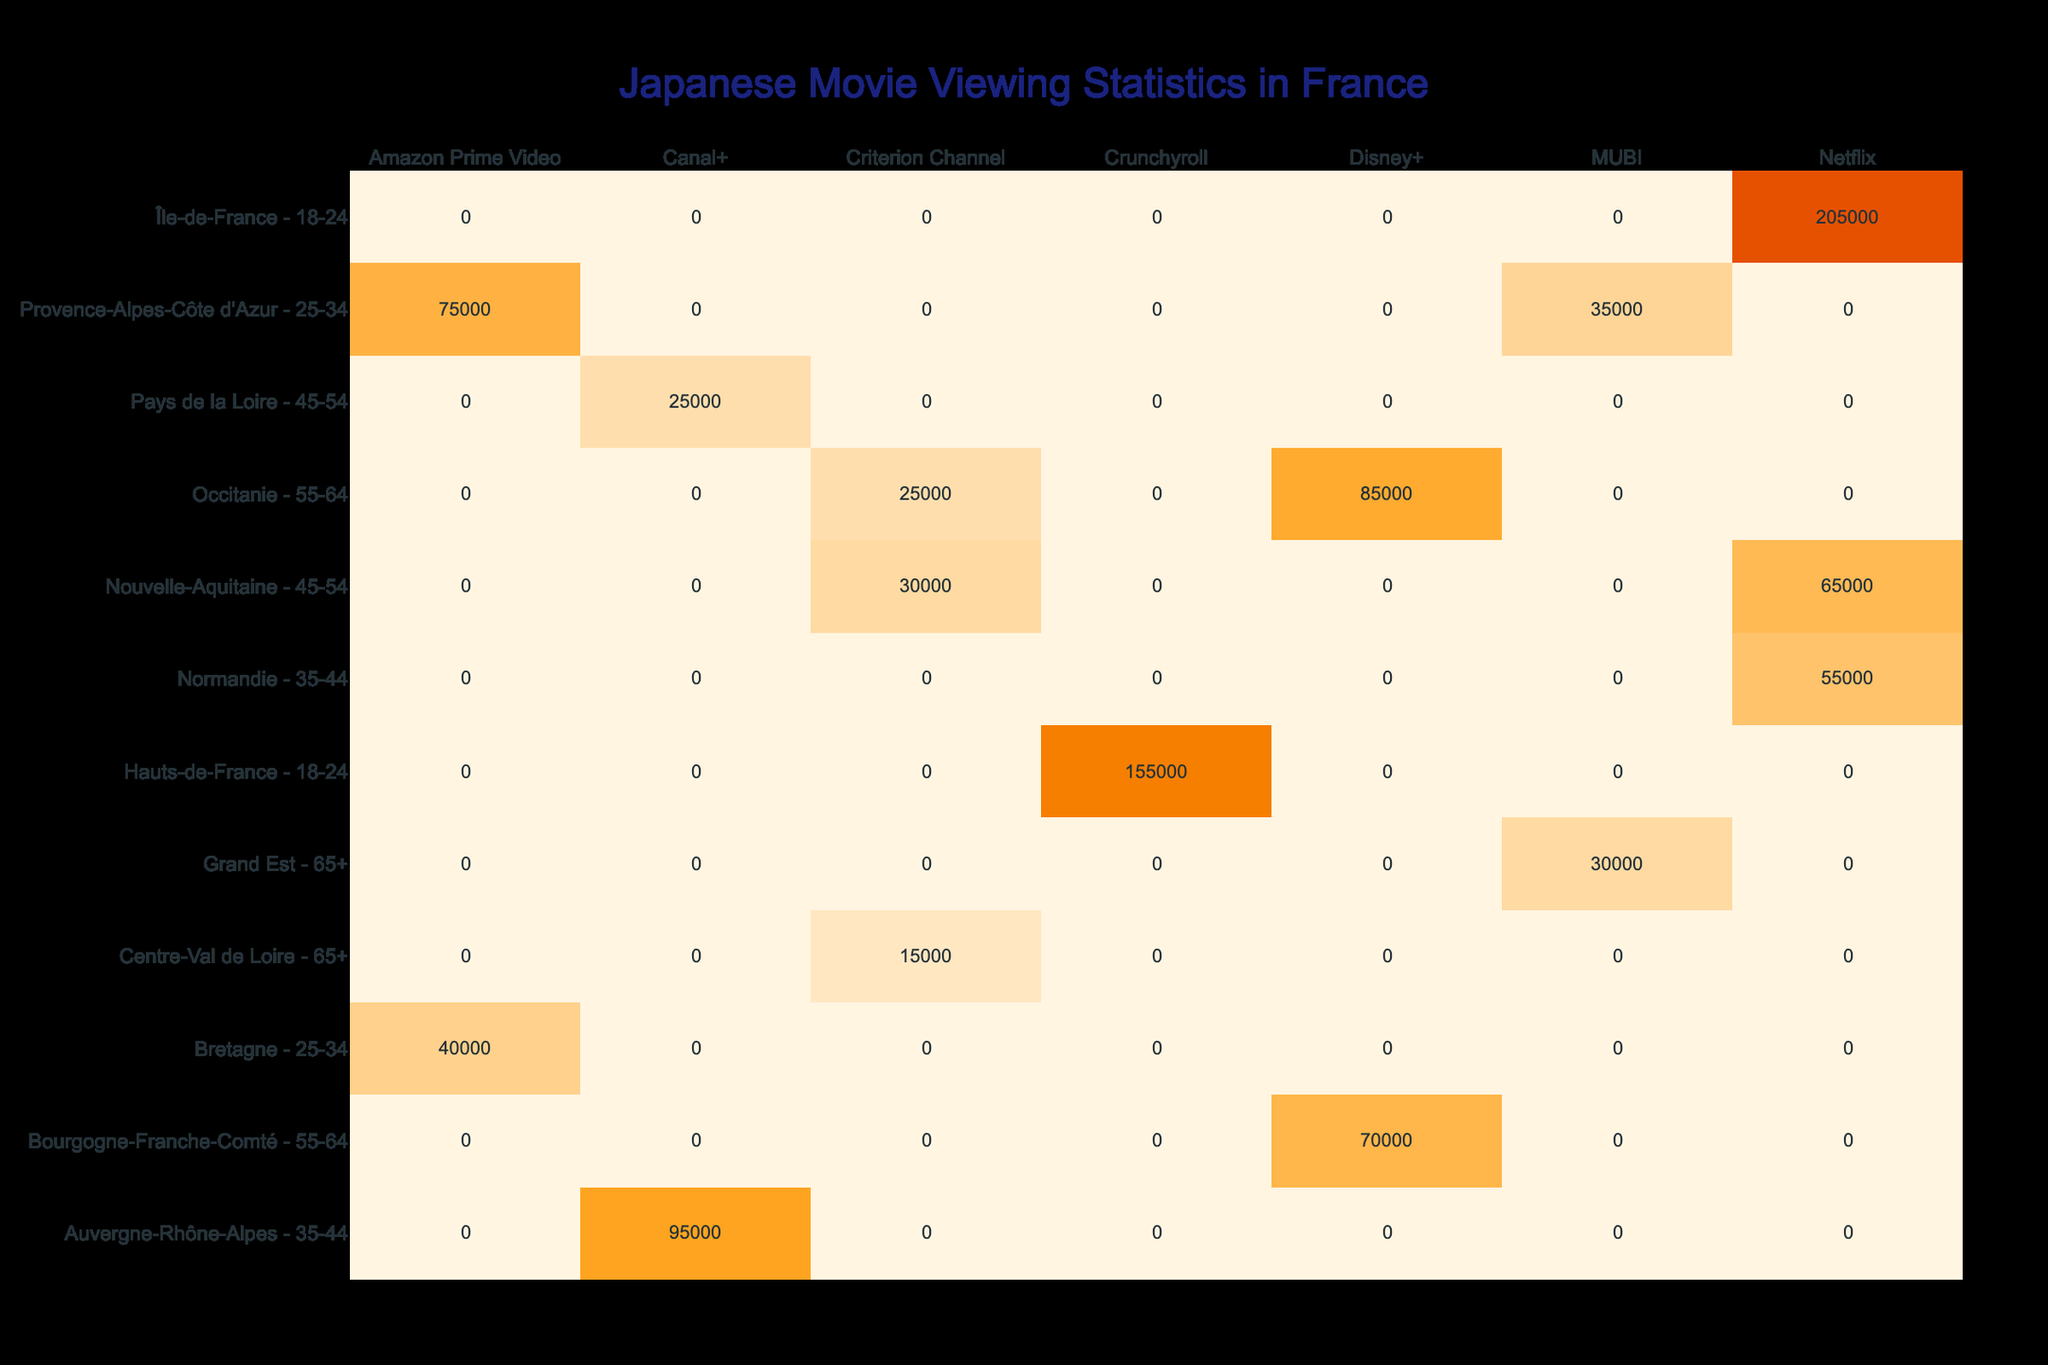What is the total number of views for movies directed by Akira Kurosawa? From the table, we see three movies directed by Akira Kurosawa: "Seven Samurai" with 30,000 views, "Ran" with 40,000 views, and "Rashomon" with 15,000 views. We can sum these values: 30,000 + 40,000 + 15,000 = 85,000.
Answer: 85,000 Which streaming platform has the highest total views among 18-24 year-olds? The table shows views for this age group on different platforms: Netflix has 125,000 and 80,000 views for "Your Name" and "One Cut of the Dead," respectively, totaling 205,000. Crunchyroll has 60,000 views for "Godzilla" and 95,000 for "Akira," totaling 155,000. Therefore, Netflix has the highest views for this age group.
Answer: Netflix What is the genre of the movie with the most views in the 55-64 age group? In the 55-64 age group, the movies listed are "Spirited Away" (85,000 views, Anime) and "Howl's Moving Castle" (70,000 views, Anime). The most viewed movie is "Spirited Away," which is an Anime.
Answer: Anime Are there more views for streaming platforms in Île-de-France than in Provence-Alpes-Côte d'Azur? In Île-de-France, the total views are 125,000 (for "Your Name") + 80,000 (for "One Cut of the Dead") = 205,000 views. In Provence-Alpes-Côte d'Azur, we have 75,000 (for "Shoplifters") + 35,000 (for "Nobody Knows") = 110,000 views. Since 205,000 is greater than 110,000, the statement is true.
Answer: Yes What is the average number of views for movies in the 45-54 age group across different regions? The 45-54 age group has the following views: 30,000 (Nouvelle-Aquitaine: "Grave of the Fireflies") + 25,000 (Pays de la Loire: "Departures") = 55,000. To find the average, we divide this by the number of entries (2), which gives us 55,000 / 2 = 27,500.
Answer: 27,500 